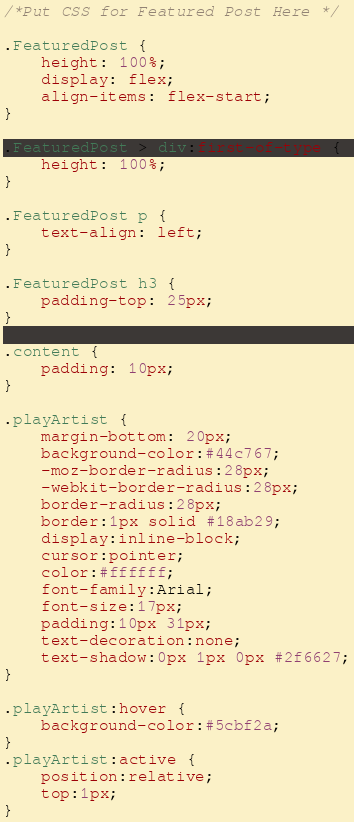Convert code to text. <code><loc_0><loc_0><loc_500><loc_500><_CSS_>/*Put CSS for Featured Post Here */

.FeaturedPost {
	height: 100%;
	display: flex;
	align-items: flex-start;
}

.FeaturedPost > div:first-of-type {
	height: 100%;
}

.FeaturedPost p {
	text-align: left;
}

.FeaturedPost h3 {
	padding-top: 25px;
}

.content {
	padding: 10px;
}

.playArtist {
	margin-bottom: 20px;
	background-color:#44c767;
	-moz-border-radius:28px;
	-webkit-border-radius:28px;
	border-radius:28px;
	border:1px solid #18ab29;
	display:inline-block;
	cursor:pointer;
	color:#ffffff;
	font-family:Arial;
	font-size:17px;
	padding:10px 31px;
	text-decoration:none;
	text-shadow:0px 1px 0px #2f6627;
}

.playArtist:hover {
	background-color:#5cbf2a;
}
.playArtist:active {
	position:relative;
	top:1px;
}


</code> 